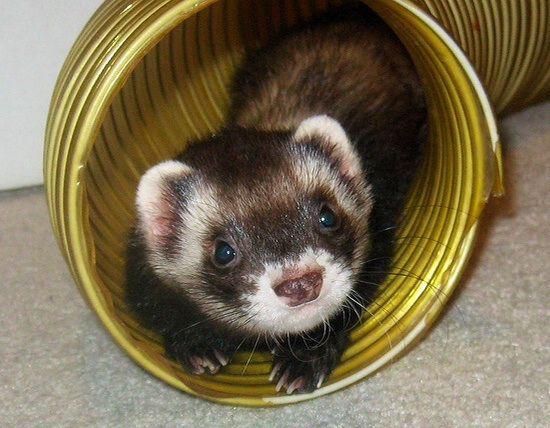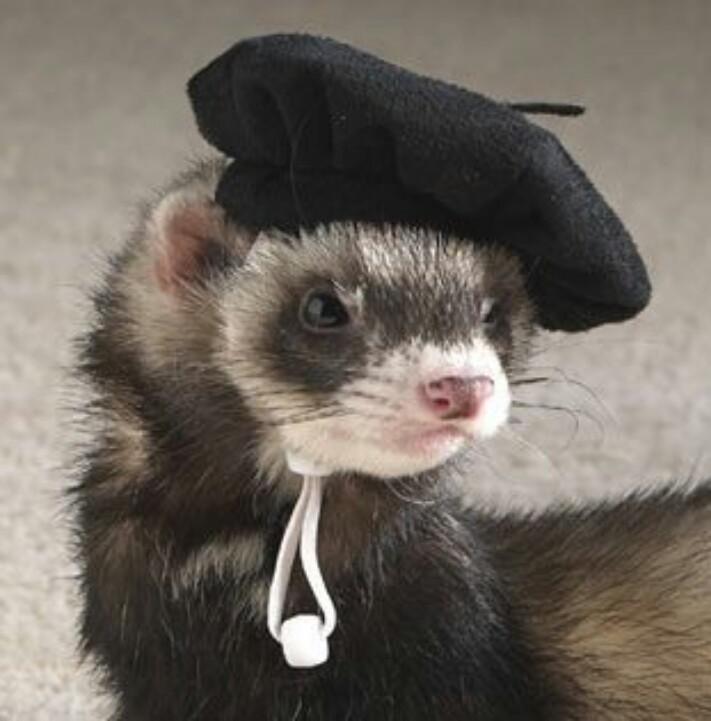The first image is the image on the left, the second image is the image on the right. For the images displayed, is the sentence "The left image contains one sleeping ferret." factually correct? Answer yes or no. No. The first image is the image on the left, the second image is the image on the right. For the images displayed, is the sentence "At least one of the ferrets is wearing something on its head." factually correct? Answer yes or no. Yes. 